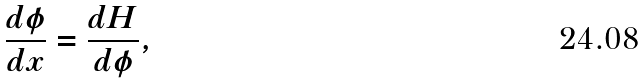Convert formula to latex. <formula><loc_0><loc_0><loc_500><loc_500>\frac { d \phi } { d x } = \frac { d H } { d \phi } ,</formula> 